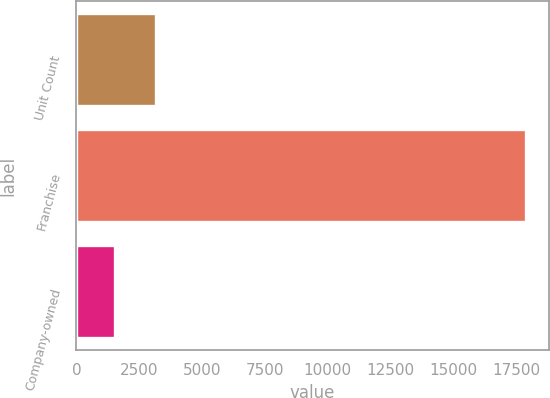Convert chart. <chart><loc_0><loc_0><loc_500><loc_500><bar_chart><fcel>Unit Count<fcel>Franchise<fcel>Company-owned<nl><fcel>3162.8<fcel>17894<fcel>1526<nl></chart> 